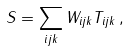<formula> <loc_0><loc_0><loc_500><loc_500>S = \sum _ { i j k } W _ { i j k } T _ { i j k } \, ,</formula> 